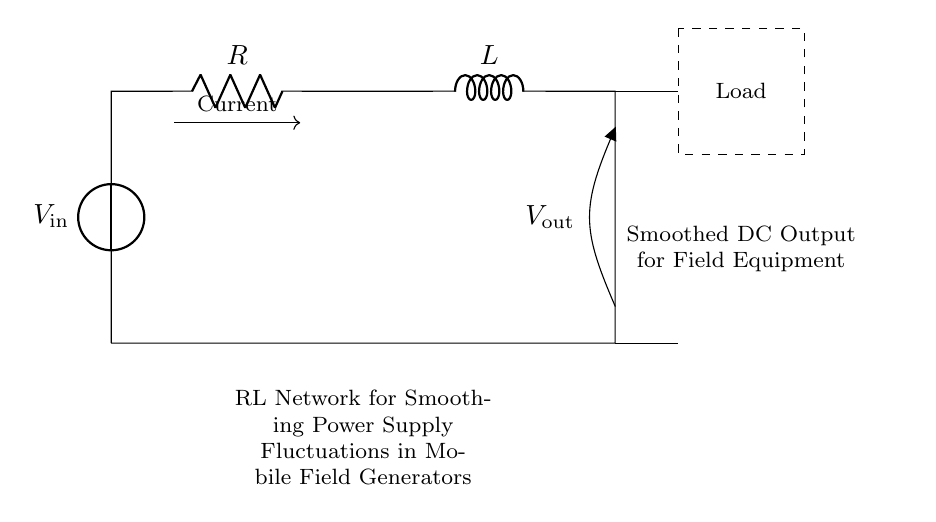What is the input voltage in the circuit? The input voltage is labeled as V_in, which denotes the voltage supplied to the circuit from the voltage source.
Answer: V_in What type of components are present in the circuit? The circuit contains a voltage source, a resistor, and an inductor, as indicated by their respective labels and symbols in the circuit diagram.
Answer: Resistor, Inductor What is the purpose of the RL network in this circuit? The RL network is designed for smoothing power supply fluctuations, which helps in providing stable voltage output for the load connected to it.
Answer: Smoothing power supply fluctuations How does the current flow in this circuit? Current flows from the voltage source through the resistor, then through the inductor, and finally towards the load, as indicated by the directional arrows in the diagram.
Answer: From V_in through R and L to Load What will happen to the output voltage during a sudden increase in input voltage? The output voltage will initially experience a rise but will gradually stabilize due to the inductor's property of opposing changes in current, leading to smoother output.
Answer: Gradual stabilization What is the role of the resistor in the RL network? The resistor limits the current flowing through the circuit and causes a voltage drop, affecting the performance of the smoothing action provided by the inductor.
Answer: Current limiting What does V_out indicate in the circuit? V_out indicates the voltage across the load, representing the smoothed DC output from the RL network intended for field equipment.
Answer: Smoothed DC output 